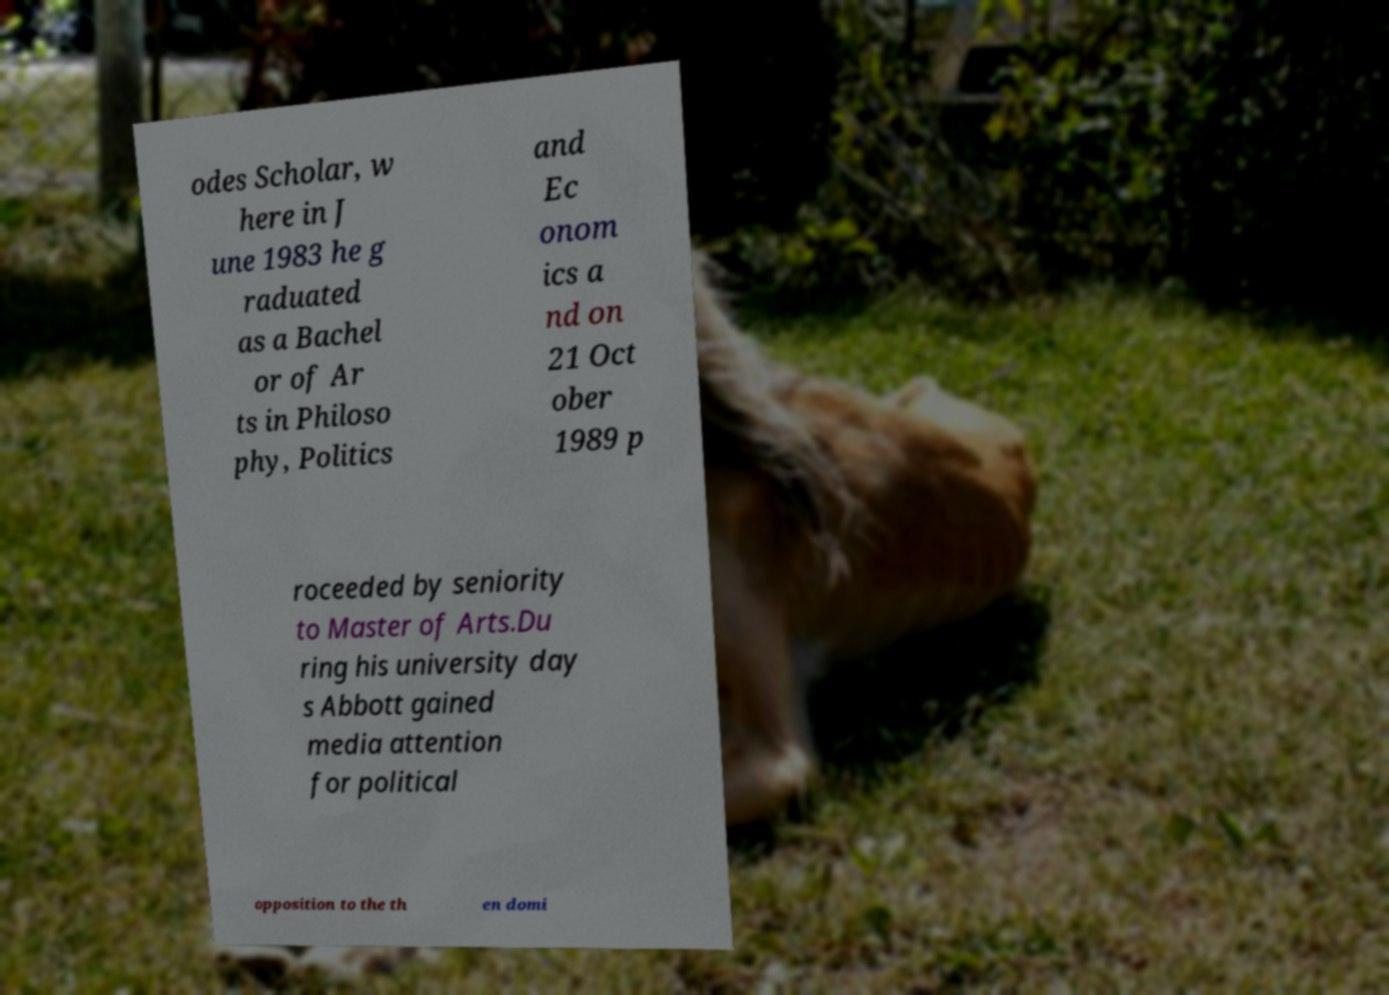There's text embedded in this image that I need extracted. Can you transcribe it verbatim? odes Scholar, w here in J une 1983 he g raduated as a Bachel or of Ar ts in Philoso phy, Politics and Ec onom ics a nd on 21 Oct ober 1989 p roceeded by seniority to Master of Arts.Du ring his university day s Abbott gained media attention for political opposition to the th en domi 